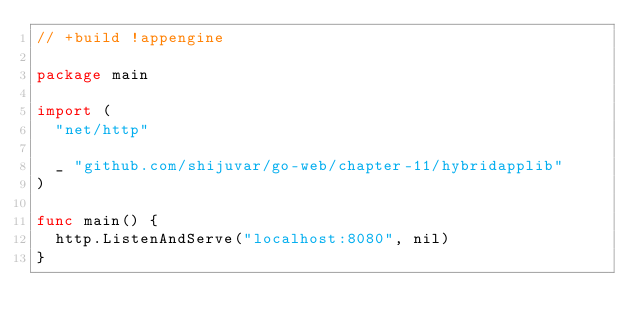Convert code to text. <code><loc_0><loc_0><loc_500><loc_500><_Go_>// +build !appengine

package main

import (
	"net/http"

	_ "github.com/shijuvar/go-web/chapter-11/hybridapplib"
)

func main() {
	http.ListenAndServe("localhost:8080", nil)
}
</code> 